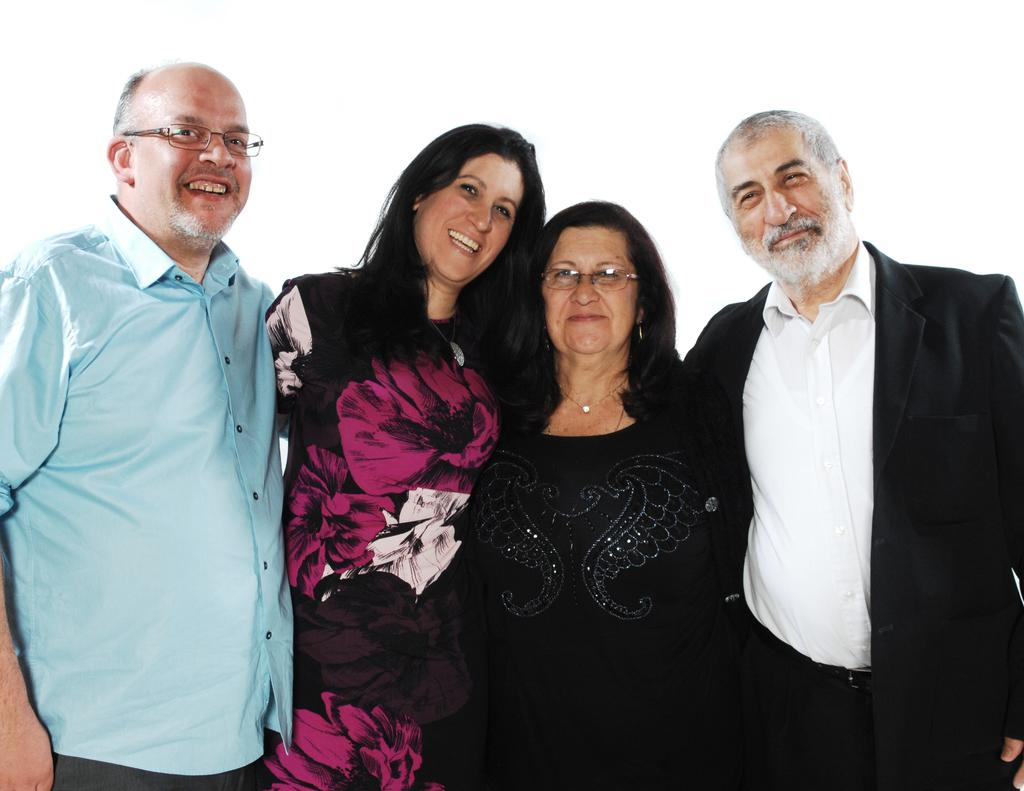How many people are in the image? There are four persons in the image. What are the persons doing in the image? The persons are standing in the image. What expressions do the persons have in the image? The persons are smiling in the image. What is the color of the background in the image? The background of the image is white in color. What type of peace symbol can be seen in the image? There is no peace symbol present in the image. How do the roots of the persons affect their stance in the image? There are no roots present in the image, as the persons are standing on their feet. 